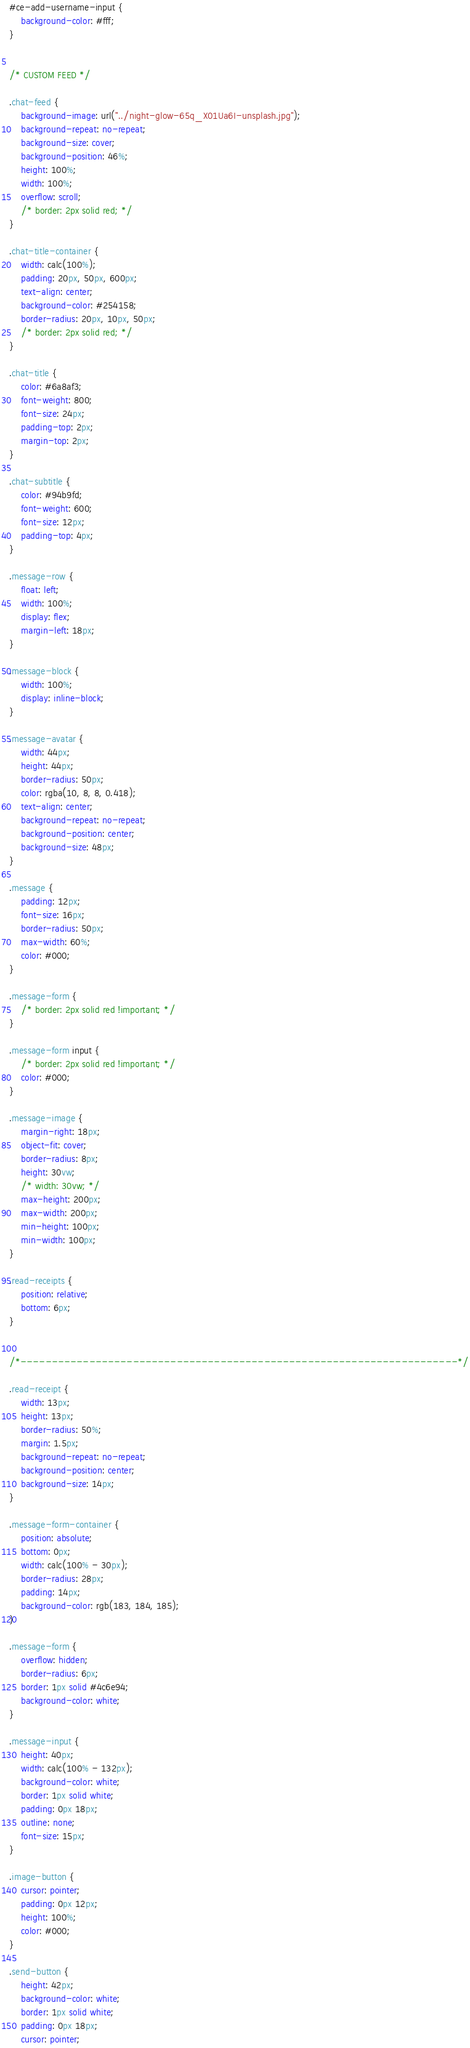Convert code to text. <code><loc_0><loc_0><loc_500><loc_500><_CSS_>#ce-add-username-input {
    background-color: #fff;
}


/* CUSTOM FEED */

.chat-feed {
    background-image: url("../night-glow-65q_X01Ua6I-unsplash.jpg");
    background-repeat: no-repeat;
    background-size: cover;
    background-position: 46%;
    height: 100%;
    width: 100%;
    overflow: scroll;
    /* border: 2px solid red; */
}

.chat-title-container {
    width: calc(100%);
    padding: 20px, 50px, 600px;
    text-align: center;
    background-color: #254158;
    border-radius: 20px, 10px, 50px;
    /* border: 2px solid red; */
}

.chat-title {
    color: #6a8af3;
    font-weight: 800;
    font-size: 24px;
    padding-top: 2px;
    margin-top: 2px;
}

.chat-subtitle {
    color: #94b9fd;
    font-weight: 600;
    font-size: 12px;
    padding-top: 4px;
}

.message-row {
    float: left;
    width: 100%;
    display: flex;
    margin-left: 18px;
}

.message-block {
    width: 100%;
    display: inline-block;
}

.message-avatar {
    width: 44px;
    height: 44px;
    border-radius: 50px;
    color: rgba(10, 8, 8, 0.418);
    text-align: center;
    background-repeat: no-repeat;
    background-position: center;
    background-size: 48px;
}

.message {
    padding: 12px;
    font-size: 16px;
    border-radius: 50px;
    max-width: 60%;
    color: #000;
}

.message-form {
    /* border: 2px solid red !important; */
}

.message-form input {
    /* border: 2px solid red !important; */
    color: #000;
}

.message-image {
    margin-right: 18px;
    object-fit: cover;
    border-radius: 8px;
    height: 30vw;
    /* width: 30vw; */
    max-height: 200px;
    max-width: 200px;
    min-height: 100px;
    min-width: 100px;
}

.read-receipts {
    position: relative;
    bottom: 6px;
}


/*----------------------------------------------------------------------*/

.read-receipt {
    width: 13px;
    height: 13px;
    border-radius: 50%;
    margin: 1.5px;
    background-repeat: no-repeat;
    background-position: center;
    background-size: 14px;
}

.message-form-container {
    position: absolute;
    bottom: 0px;
    width: calc(100% - 30px);
    border-radius: 28px;
    padding: 14px;
    background-color: rgb(183, 184, 185);
}

.message-form {
    overflow: hidden;
    border-radius: 6px;
    border: 1px solid #4c6e94;
    background-color: white;
}

.message-input {
    height: 40px;
    width: calc(100% - 132px);
    background-color: white;
    border: 1px solid white;
    padding: 0px 18px;
    outline: none;
    font-size: 15px;
}

.image-button {
    cursor: pointer;
    padding: 0px 12px;
    height: 100%;
    color: #000;
}

.send-button {
    height: 42px;
    background-color: white;
    border: 1px solid white;
    padding: 0px 18px;
    cursor: pointer;</code> 